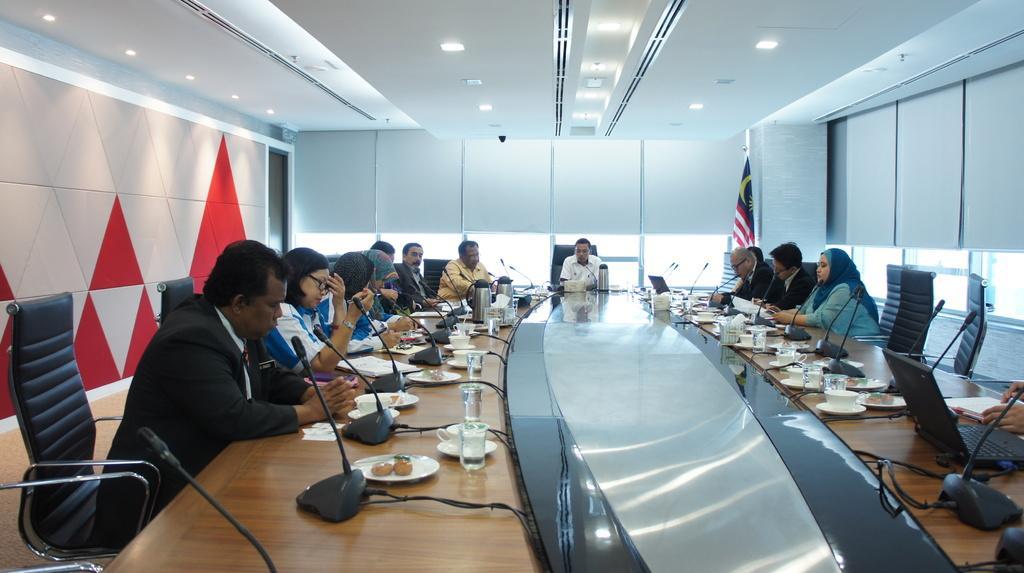Can you describe this image briefly? In the image we can see group of persons were sitting on the chair around the table. On table there is a microphone,plate,glasses,cup,saucer and tissue paper. In background there is a wall,glass,light and flag. 